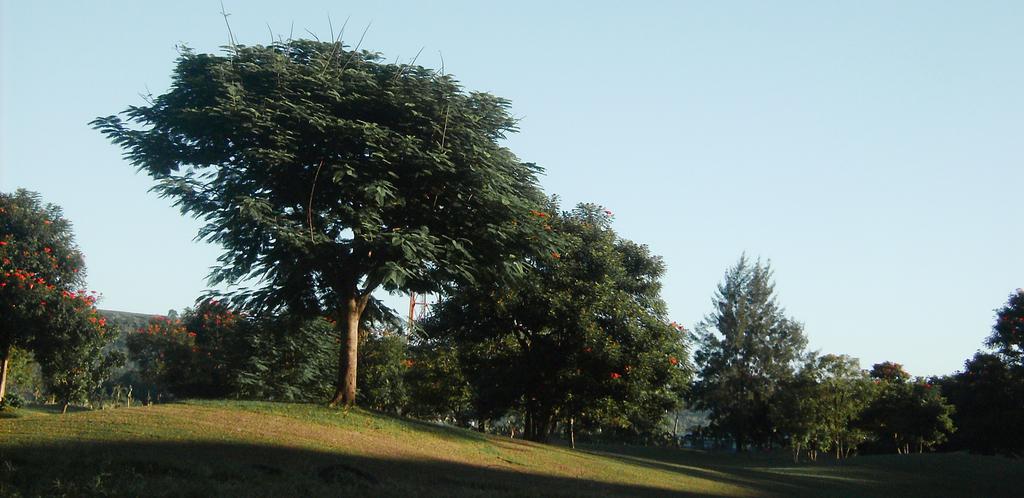In one or two sentences, can you explain what this image depicts? In this image we can see the trees and also the ground. In the background we can see the sky. 